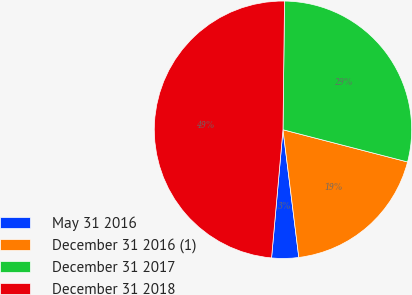<chart> <loc_0><loc_0><loc_500><loc_500><pie_chart><fcel>May 31 2016<fcel>December 31 2016 (1)<fcel>December 31 2017<fcel>December 31 2018<nl><fcel>3.38%<fcel>19.01%<fcel>28.84%<fcel>48.77%<nl></chart> 